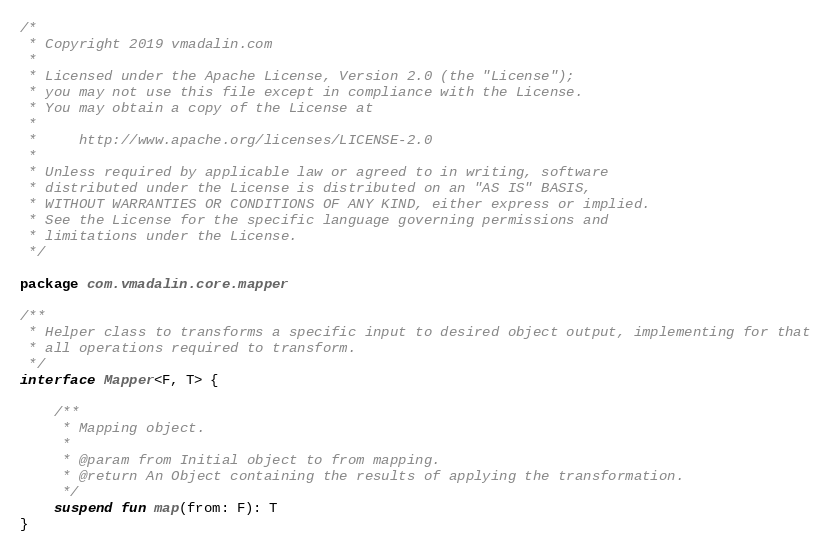<code> <loc_0><loc_0><loc_500><loc_500><_Kotlin_>/*
 * Copyright 2019 vmadalin.com
 *
 * Licensed under the Apache License, Version 2.0 (the "License");
 * you may not use this file except in compliance with the License.
 * You may obtain a copy of the License at
 *
 *     http://www.apache.org/licenses/LICENSE-2.0
 *
 * Unless required by applicable law or agreed to in writing, software
 * distributed under the License is distributed on an "AS IS" BASIS,
 * WITHOUT WARRANTIES OR CONDITIONS OF ANY KIND, either express or implied.
 * See the License for the specific language governing permissions and
 * limitations under the License.
 */

package com.vmadalin.core.mapper

/**
 * Helper class to transforms a specific input to desired object output, implementing for that
 * all operations required to transform.
 */
interface Mapper<F, T> {

    /**
     * Mapping object.
     *
     * @param from Initial object to from mapping.
     * @return An Object containing the results of applying the transformation.
     */
    suspend fun map(from: F): T
}
</code> 